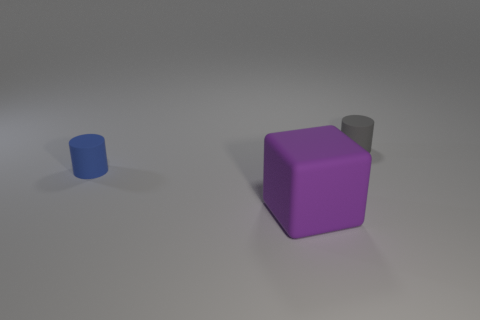Add 3 cyan metal spheres. How many objects exist? 6 Subtract all blocks. How many objects are left? 2 Subtract 0 yellow cylinders. How many objects are left? 3 Subtract all big red rubber cubes. Subtract all tiny gray rubber objects. How many objects are left? 2 Add 2 purple matte objects. How many purple matte objects are left? 3 Add 2 gray rubber things. How many gray rubber things exist? 3 